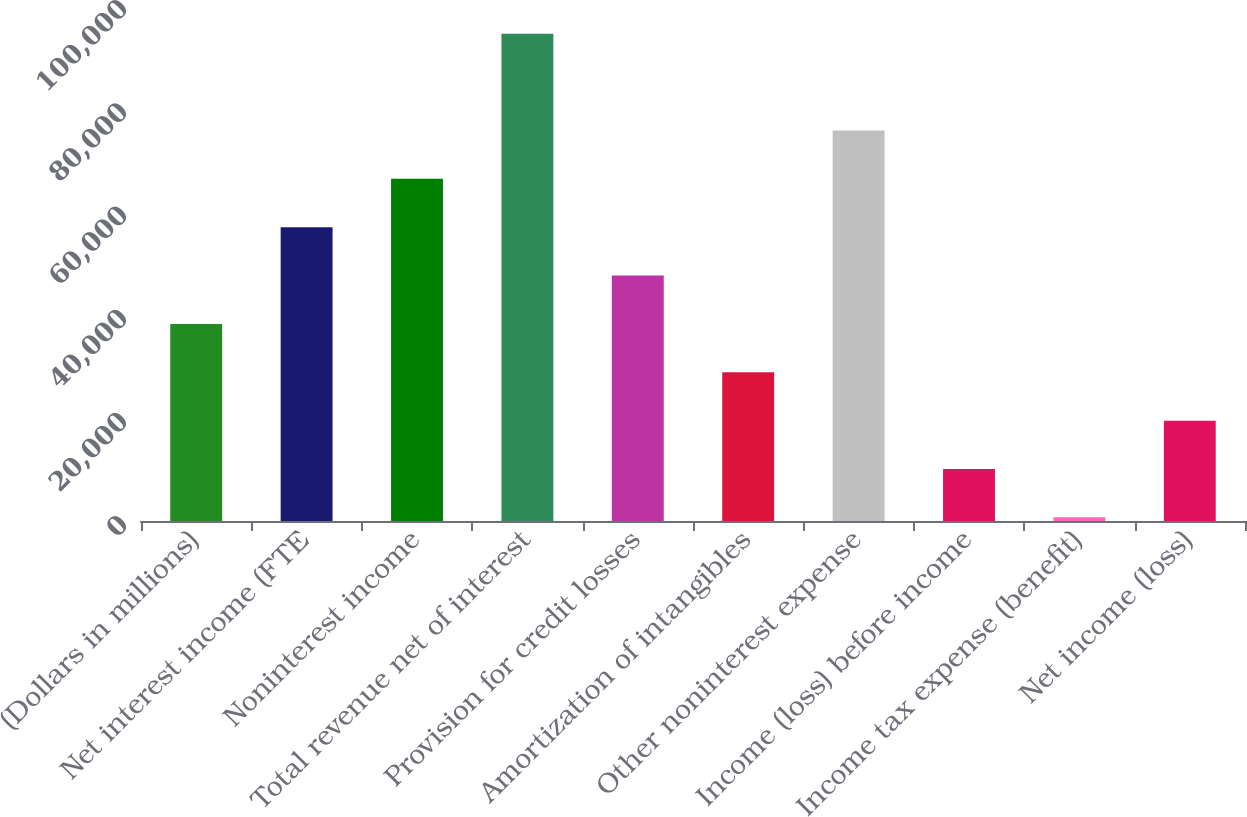<chart> <loc_0><loc_0><loc_500><loc_500><bar_chart><fcel>(Dollars in millions)<fcel>Net interest income (FTE<fcel>Noninterest income<fcel>Total revenue net of interest<fcel>Provision for credit losses<fcel>Amortization of intangibles<fcel>Other noninterest expense<fcel>Income (loss) before income<fcel>Income tax expense (benefit)<fcel>Net income (loss)<nl><fcel>38192.8<fcel>56937.2<fcel>66309.4<fcel>94426<fcel>47565<fcel>28820.6<fcel>75681.6<fcel>10076.2<fcel>704<fcel>19448.4<nl></chart> 